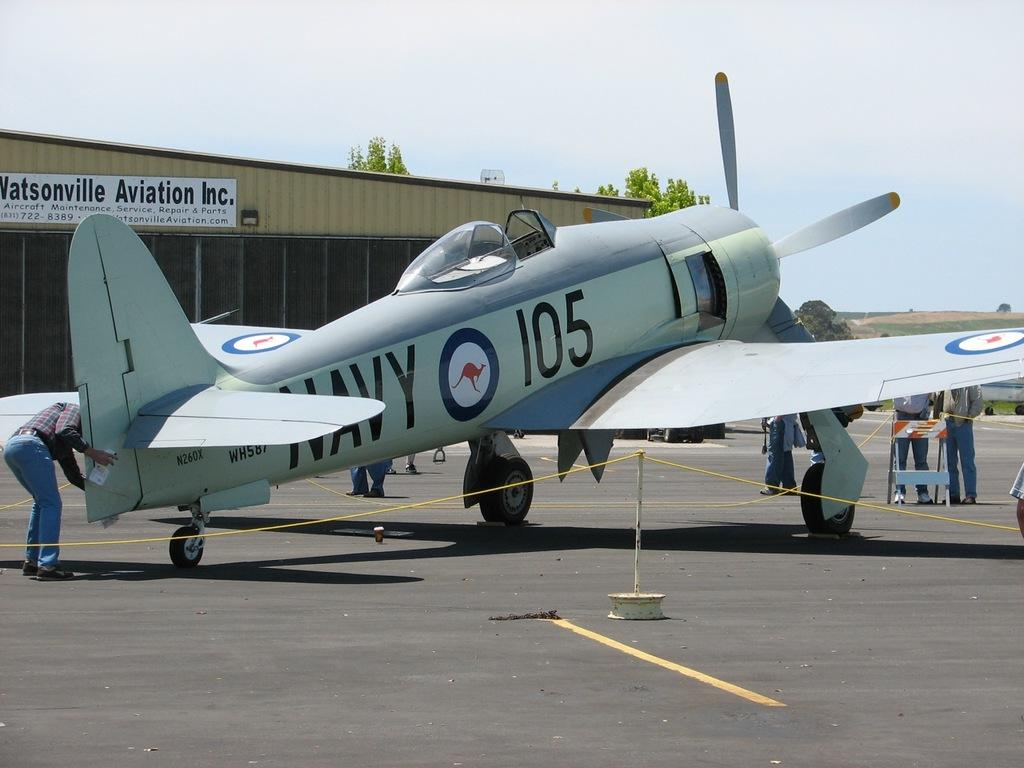<image>
Describe the image concisely. Navy 105 was getting inspected for the Watsonville Aviation Inc. 